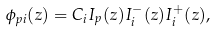<formula> <loc_0><loc_0><loc_500><loc_500>\phi _ { p i } ( z ) = C _ { i } I _ { p } ( z ) I _ { i } ^ { - } ( z ) I _ { i } ^ { + } ( z ) ,</formula> 